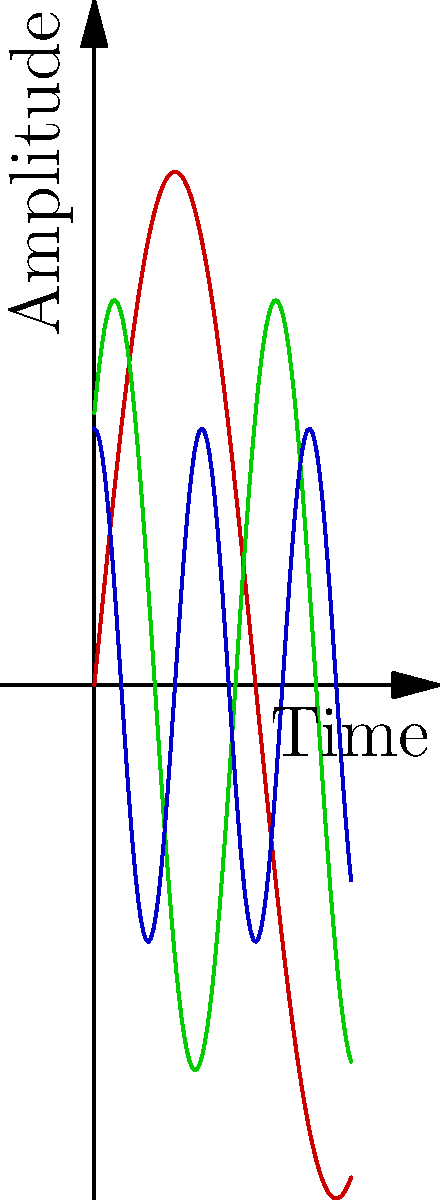Analyze the visual rhythm represented by the three sinusoidal waves in the image. How might these patterns relate to the meter and flow of a poem, and which wave would best represent a calm, introspective piece of calligraphy? To analyze the visual rhythm and its relation to poetic meter and calligraphy, let's break down the image and its components:

1. The image shows three sinusoidal waves of different colors:
   - Red wave: Highest amplitude, lowest frequency
   - Green wave: Medium amplitude, medium frequency
   - Blue wave: Lowest amplitude, highest frequency

2. In poetry and calligraphy, rhythm can be thought of in terms of:
   - Amplitude: The intensity or emphasis of each beat
   - Frequency: How often the beats occur
   - Phase: The timing or offset of the beats

3. Relating the waves to poetic meter:
   - The red wave could represent a slow, emphatic meter (e.g., spondaic)
   - The green wave might symbolize a balanced, moderate meter (e.g., iambic)
   - The blue wave could indicate a quick, light meter (e.g., dactylic)

4. In calligraphy, these waves could represent:
   - Red: Bold, dramatic strokes with long pauses
   - Green: Balanced strokes with regular spacing
   - Blue: Quick, delicate strokes in rapid succession

5. For a calm, introspective piece of calligraphy:
   - We would want a rhythm that is neither too intense nor too rapid
   - The green wave offers a balanced approach with moderate amplitude and frequency
   - This represents a steady, contemplative flow in both poetry and calligraphic strokes

Therefore, the green wave would best represent a calm, introspective piece of calligraphy, as it embodies a balanced rhythm that allows for both emphasis and flow without being too extreme in either direction.
Answer: The green wave, with its moderate amplitude and frequency, best represents a calm, introspective piece of calligraphy. 